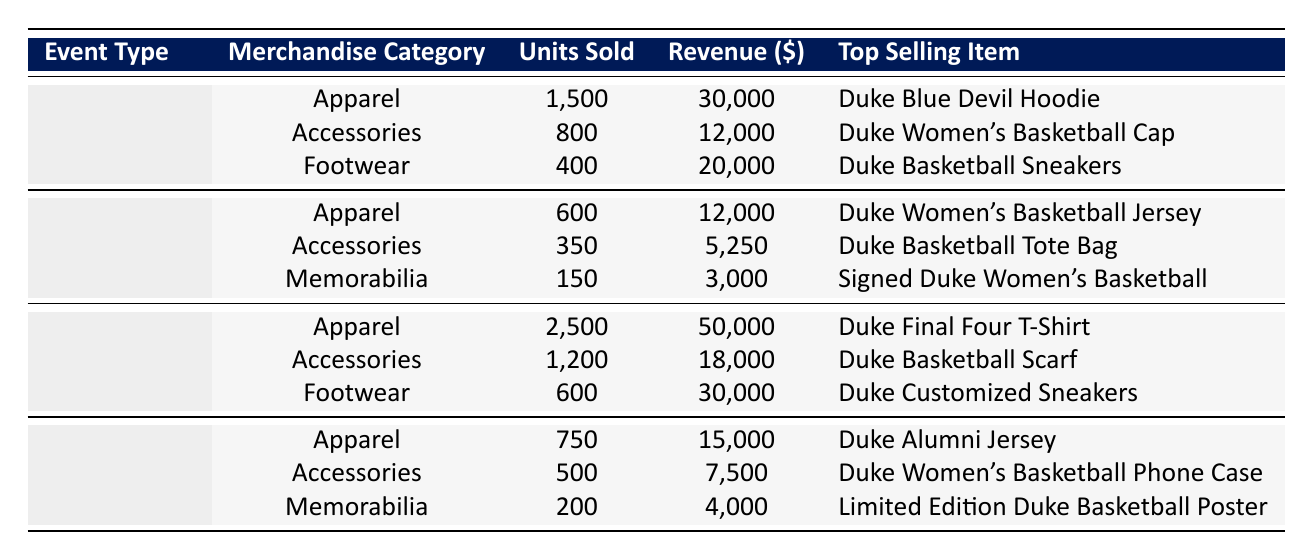What is the total revenue from merchandise sold during Home Games? To find the total revenue for Home Games, add all the revenue values from that section: 30,000 + 12,000 + 20,000 = 62,000.
Answer: 62000 Which merchandise category sold the most units during the Tournament? In the Tournament section, Apparel has the highest units sold at 2,500. The other categories sold 1,200 and 600 units.
Answer: Apparel Did more units of accessories or memorabilia sell during Away Games? In the Away Games section, Accessories sold 350 units, while Memorabilia sold 150 units. Therefore, Accessories sold more units.
Answer: Yes What is the top-selling item during Special Events? The top-selling item for Special Events is the Duke Alumni Jersey, as stated in the table.
Answer: Duke Alumni Jersey What is the average revenue per unit sold for Footwear during Tournament events? For Footwear in the Tournament, the revenue is 30,000 and units sold are 600. The average revenue per unit is calculated as 30,000 / 600 = 50.
Answer: 50 What is the total number of units sold across all categories during Home Games? To find the total units sold during Home Games, add the units from each category: 1,500 + 800 + 400 = 2,700.
Answer: 2700 Which event type generated the highest revenue overall? The Tournament event type generated the highest revenue of 50,000 (Apparel) + 18,000 (Accessories) + 30,000 (Footwear) = 98,000, which is greater than the other event types.
Answer: Tournament Is the Duke Women's Basketball Cap more popular than the Duke Basketball Tote Bag? The Duke Women's Basketball Cap sold 800 units while the Duke Basketball Tote Bag sold 350 units. Therefore, the Cap is more popular.
Answer: Yes What is the total revenue from all merchandise sold during Away Games? To calculate the total revenue for Away Games, add the individual revenues: 12,000 + 5,250 + 3,000 = 20,250.
Answer: 20250 How many more units of Apparel were sold during Tournaments than during Special Events? For Tournaments, Apparel sold 2,500 units, while for Special Events, Apparel sold 750 units. The difference is 2,500 - 750 = 1,750 units.
Answer: 1750 